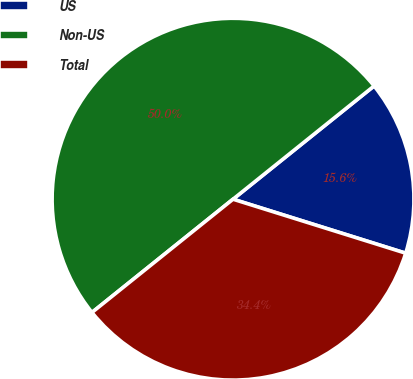Convert chart. <chart><loc_0><loc_0><loc_500><loc_500><pie_chart><fcel>US<fcel>Non-US<fcel>Total<nl><fcel>15.59%<fcel>50.0%<fcel>34.41%<nl></chart> 